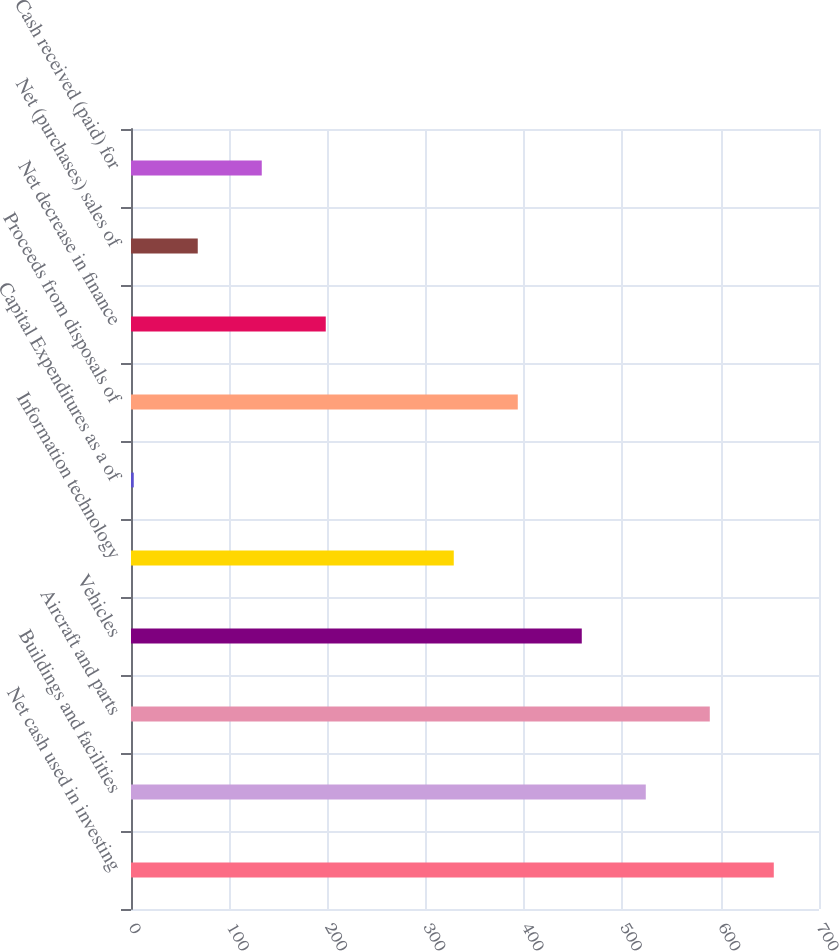Convert chart to OTSL. <chart><loc_0><loc_0><loc_500><loc_500><bar_chart><fcel>Net cash used in investing<fcel>Buildings and facilities<fcel>Aircraft and parts<fcel>Vehicles<fcel>Information technology<fcel>Capital Expenditures as a of<fcel>Proceeds from disposals of<fcel>Net decrease in finance<fcel>Net (purchases) sales of<fcel>Cash received (paid) for<nl><fcel>654<fcel>523.76<fcel>588.88<fcel>458.64<fcel>328.4<fcel>2.8<fcel>393.52<fcel>198.16<fcel>67.92<fcel>133.04<nl></chart> 